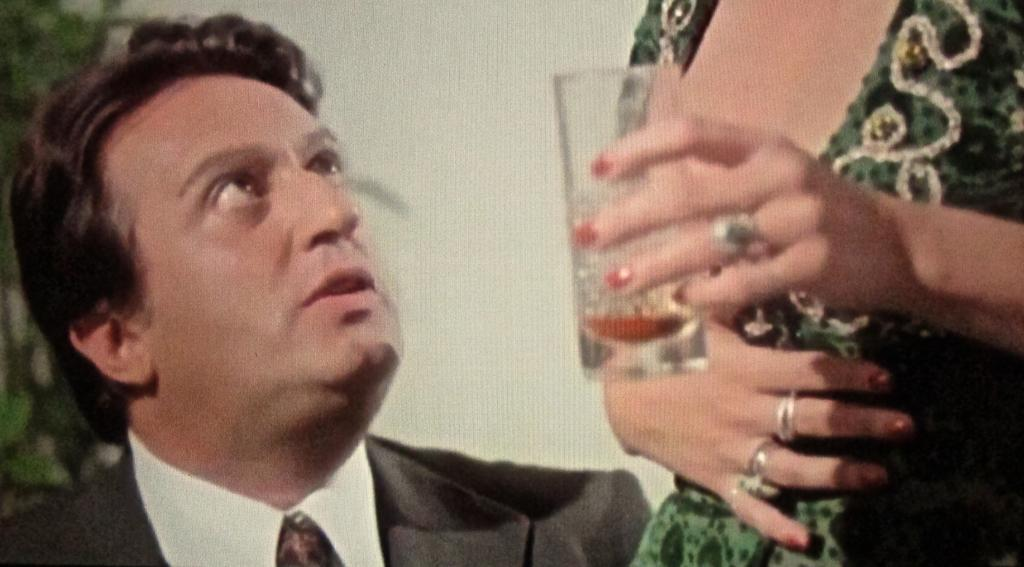How many people are in the image? There are people in the image, but the exact number is not specified. Can you describe the actions of any of the people in the image? Yes, there is a person holding a drink glass at the right side of the image. What type of game is being played in the cemetery in the image? There is no game or cemetery present in the image; it features people, including one holding a drink glass. 